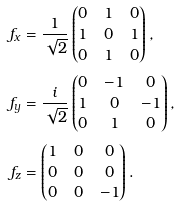Convert formula to latex. <formula><loc_0><loc_0><loc_500><loc_500>f _ { x } & = \frac { 1 } { \sqrt { 2 } } \begin{pmatrix} 0 & 1 & 0 \\ 1 & 0 & 1 \\ 0 & 1 & 0 \end{pmatrix} , \\ f _ { y } & = \frac { i } { \sqrt { 2 } } \begin{pmatrix} 0 & - 1 & 0 \\ 1 & 0 & - 1 \\ 0 & 1 & 0 \end{pmatrix} , \\ f _ { z } & = \begin{pmatrix} 1 & 0 & 0 \\ 0 & 0 & 0 \\ 0 & 0 & - 1 \end{pmatrix} .</formula> 